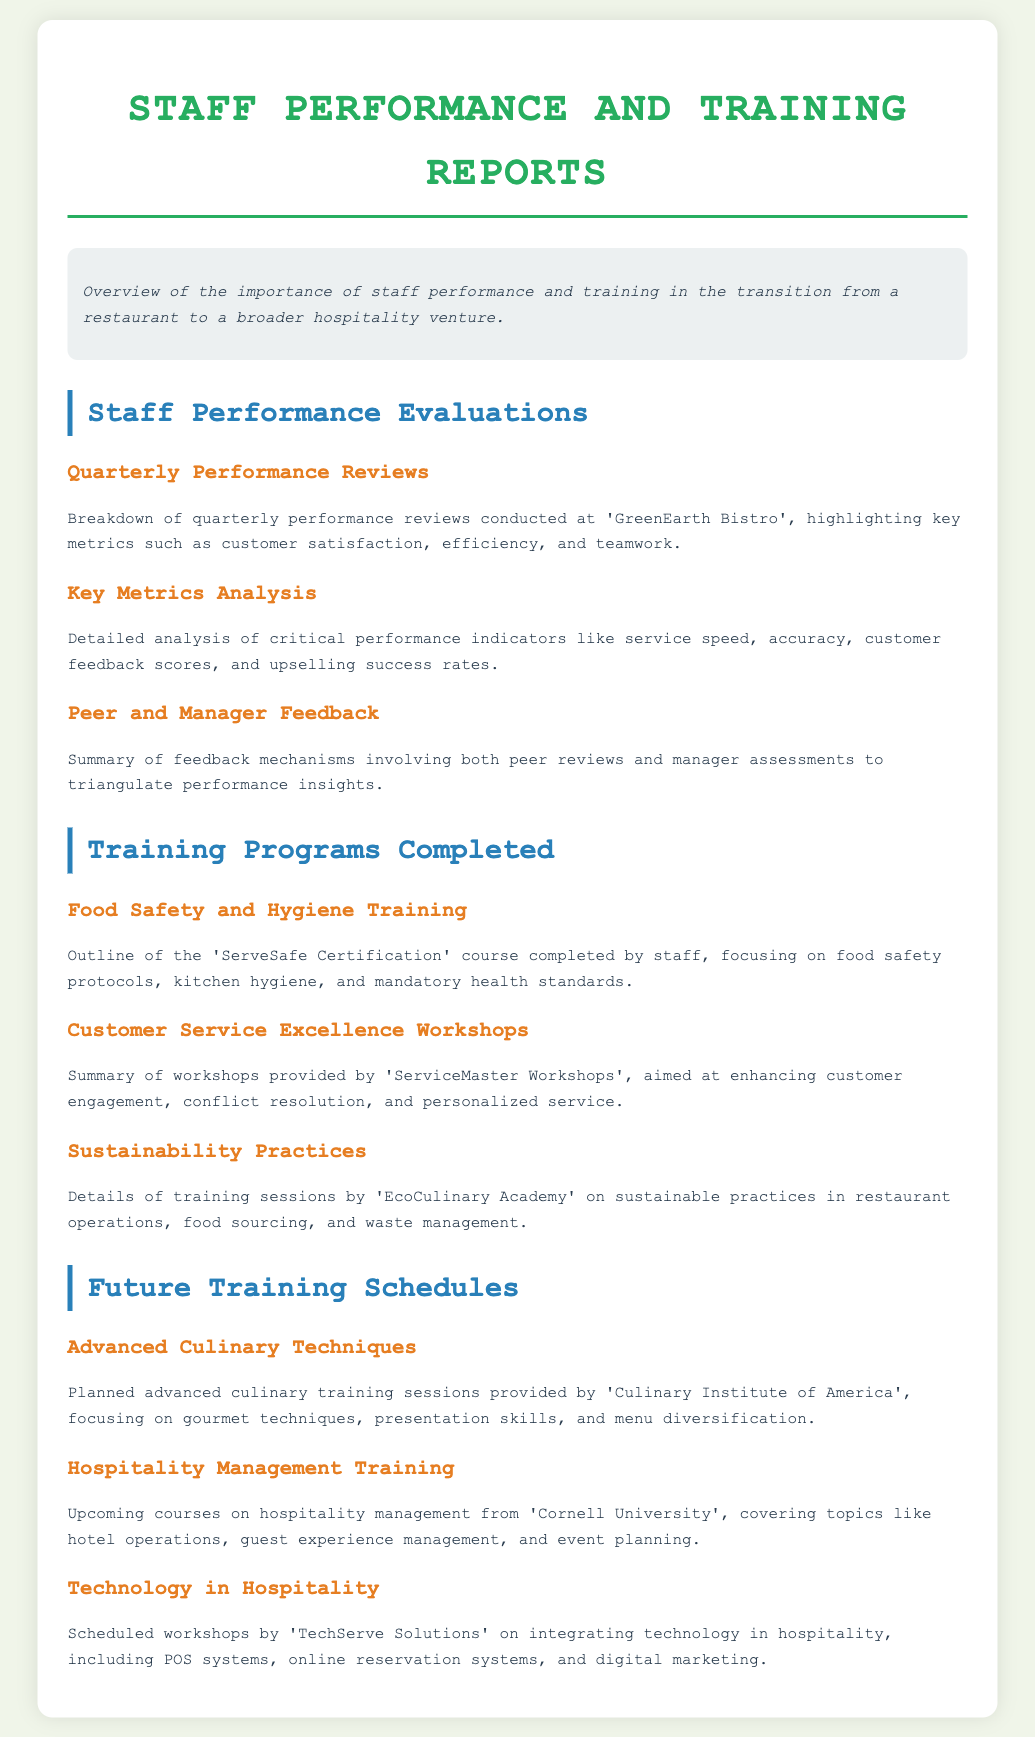What is the title of the document? The title of the document is provided in the header of the document, which is "Staff Performance and Training Reports".
Answer: Staff Performance and Training Reports What training program focused on food safety? The document outlines various training programs, specifically mentioning one focused on food safety protocols and kitchen hygiene.
Answer: ServeSafe Certification Who conducted the customer service workshops? The document provides the name of the entity that provided the customer service training workshops, which is referenced in the section about training programs.
Answer: ServiceMaster Workshops What is the upcoming course covering hotel operations? The future training schedules section lists courses and one of them focuses on hotel operations and guest experience management.
Answer: Hospitality Management Training Which organization will provide advanced culinary training? The document specifies the organization responsible for the planned advanced culinary training sessions.
Answer: Culinary Institute of America What are the key metrics analyzed in the performance evaluations? The breakdown of performance evaluations includes specific metrics, which highlight important aspects of staff performance in the restaurant.
Answer: Service speed, accuracy, customer feedback scores, upselling success rates What type of training is planned regarding technology? The future training schedule mentions certain workshops that focus on integrating technology into hospitality.
Answer: Technology in Hospitality What was the purpose of the sustainability practices training? The document states the focus of the training sessions provided by a specific academy, emphasizing the importance of sustainable operations.
Answer: Sustainable practices in restaurant operations Which entity will provide workshops on integrating technology? The document specifies which organization is responsible for the scheduled workshops on technology integration in hospitality.
Answer: TechServe Solutions 